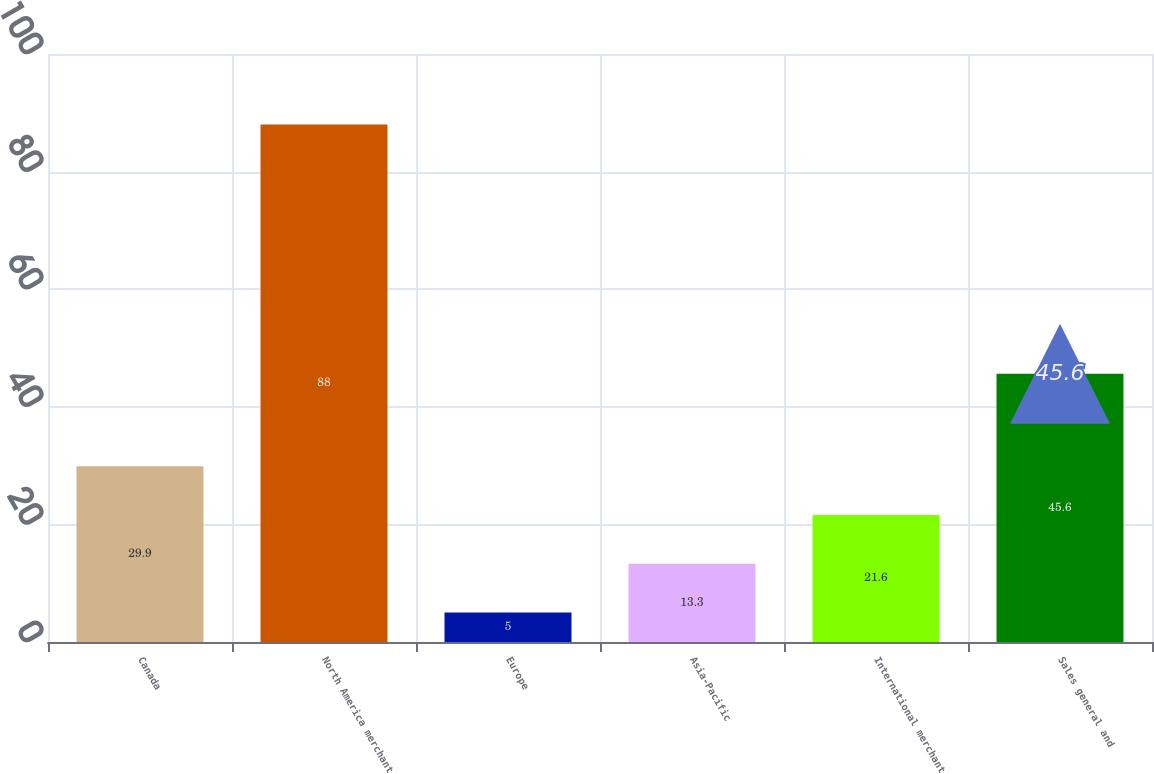Convert chart. <chart><loc_0><loc_0><loc_500><loc_500><bar_chart><fcel>Canada<fcel>North America merchant<fcel>Europe<fcel>Asia-Pacific<fcel>International merchant<fcel>Sales general and<nl><fcel>29.9<fcel>88<fcel>5<fcel>13.3<fcel>21.6<fcel>45.6<nl></chart> 